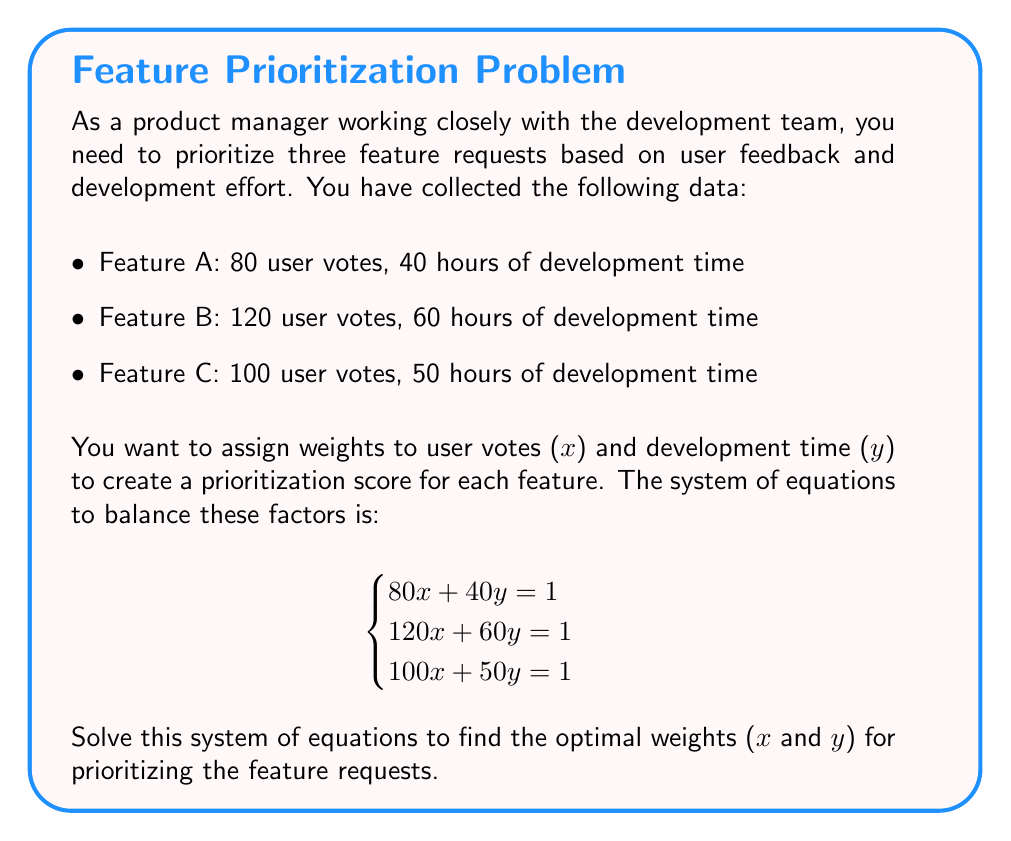Show me your answer to this math problem. To solve this system of linear equations, we'll use the elimination method:

1) First, let's subtract the first equation from the second and third equations:
   $$\begin{cases}
   80x + 40y = 1 \\
   40x + 20y = 0 \\
   20x + 10y = 0
   \end{cases}$$

2) Simplify the second and third equations:
   $$\begin{cases}
   80x + 40y = 1 \\
   2x + y = 0 \\
   2x + y = 0
   \end{cases}$$

3) We can see that the second and third equations are identical, so we can discard one:
   $$\begin{cases}
   80x + 40y = 1 \\
   2x + y = 0
   \end{cases}$$

4) From the second equation, we can express y in terms of x:
   $y = -2x$

5) Substitute this into the first equation:
   $80x + 40(-2x) = 1$
   $80x - 80x = 1$
   $0 = 1$

6) This contradiction means that there is no unique solution that satisfies all three original equations simultaneously.

7) However, we can find a least-squares solution using the pseudoinverse method:

   Let $A = \begin{bmatrix} 80 & 40 \\ 120 & 60 \\ 100 & 50 \end{bmatrix}$ and $b = \begin{bmatrix} 1 \\ 1 \\ 1 \end{bmatrix}$

   The least-squares solution is given by $x = (A^TA)^{-1}A^Tb$

8) Calculate $A^TA$:
   $A^TA = \begin{bmatrix} 80 & 120 & 100 \\ 40 & 60 & 50 \end{bmatrix} \begin{bmatrix} 80 & 40 \\ 120 & 60 \\ 100 & 50 \end{bmatrix} = \begin{bmatrix} 50000 & 25000 \\ 25000 & 12500 \end{bmatrix}$

9) Calculate $(A^TA)^{-1}$:
   $(A^TA)^{-1} = \frac{1}{50000 \cdot 12500 - 25000^2} \begin{bmatrix} 12500 & -25000 \\ -25000 & 50000 \end{bmatrix} = \begin{bmatrix} 0.0002 & -0.0001 \\ -0.0001 & 0.0002 \end{bmatrix}$

10) Calculate $A^Tb$:
    $A^Tb = \begin{bmatrix} 80 & 120 & 100 \\ 40 & 60 & 50 \end{bmatrix} \begin{bmatrix} 1 \\ 1 \\ 1 \end{bmatrix} = \begin{bmatrix} 300 \\ 150 \end{bmatrix}$

11) Finally, calculate $x = (A^TA)^{-1}A^Tb$:
    $x = \begin{bmatrix} 0.0002 & -0.0001 \\ -0.0001 & 0.0002 \end{bmatrix} \begin{bmatrix} 300 \\ 150 \end{bmatrix} = \begin{bmatrix} 0.0045 \\ 0.0075 \end{bmatrix}$

Therefore, the optimal weights are approximately $x = 0.0045$ for user votes and $y = 0.0075$ for development time.
Answer: $x \approx 0.0045, y \approx 0.0075$ 